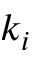<formula> <loc_0><loc_0><loc_500><loc_500>k _ { i }</formula> 